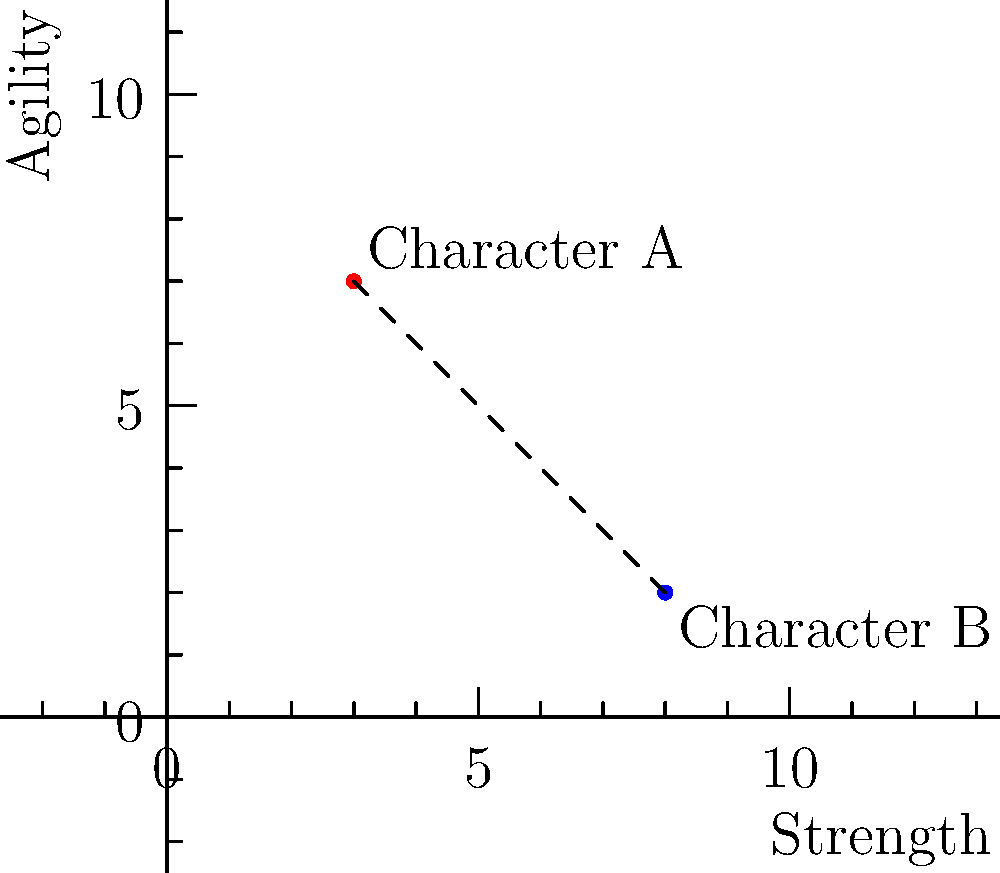In a character stat tracking app, two characters' stats are plotted on a 2D graph where the x-axis represents Strength and the y-axis represents Agility. Character A has stats (3, 7) and Character B has stats (8, 2). Calculate the distance between these two character stat points using the distance formula. To calculate the distance between two points on a 2D graph, we use the distance formula:

$$d = \sqrt{(x_2 - x_1)^2 + (y_2 - y_1)^2}$$

Where $(x_1, y_1)$ are the coordinates of the first point and $(x_2, y_2)$ are the coordinates of the second point.

Let's plug in our values:
- Character A: $(x_1, y_1) = (3, 7)$
- Character B: $(x_2, y_2) = (8, 2)$

Now, let's solve step-by-step:

1) $d = \sqrt{(8 - 3)^2 + (2 - 7)^2}$

2) $d = \sqrt{5^2 + (-5)^2}$

3) $d = \sqrt{25 + 25}$

4) $d = \sqrt{50}$

5) $d = 5\sqrt{2}$

Therefore, the distance between the two character stat points is $5\sqrt{2}$ units.
Answer: $5\sqrt{2}$ units 